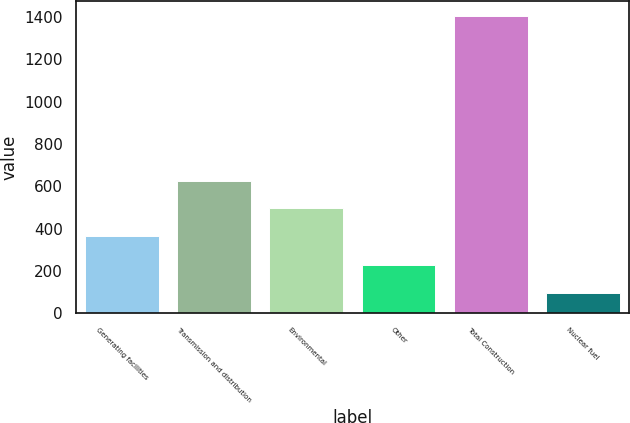Convert chart. <chart><loc_0><loc_0><loc_500><loc_500><bar_chart><fcel>Generating facilities<fcel>Transmission and distribution<fcel>Environmental<fcel>Other<fcel>Total Construction<fcel>Nuclear fuel<nl><fcel>365<fcel>627.2<fcel>496.1<fcel>227.1<fcel>1407<fcel>96<nl></chart> 